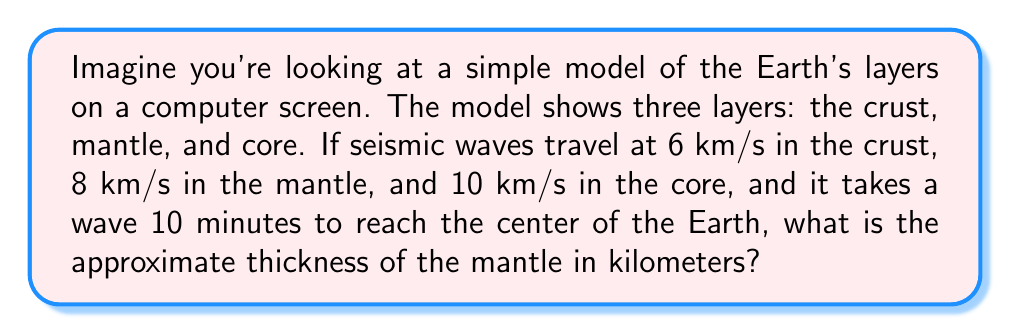Teach me how to tackle this problem. Let's break this down step-by-step:

1) First, we need to convert the time from minutes to seconds:
   10 minutes = 10 × 60 = 600 seconds

2) Now, we know that distance = speed × time. The total distance is the radius of the Earth, which we'll calculate.

3) We don't know the exact thickness of each layer, but we can make some assumptions based on general knowledge:
   - The crust is relatively thin, let's assume it's about 30 km thick
   - The core is about half the Earth's radius

4) Let's calculate the total distance the wave travels:
   $$ \text{Total distance} = 6 \frac{\text{km}}{\text{s}} \times 30\text{s} + 8 \frac{\text{km}}{\text{s}} \times t_1 + 10 \frac{\text{km}}{\text{s}} \times t_2 = 600\text{ km} $$
   Where $t_1$ is the time in the mantle and $t_2$ is the time in the core

5) We know that $t_1 + t_2 = 570\text{s}$ (600s - 30s in the crust)

6) If the core is half the radius, then $t_2 = \frac{570}{2} = 285\text{s}$

7) So, $t_1 = 570 - 285 = 285\text{s}$

8) Now we can calculate the distance traveled in the mantle:
   $$ \text{Mantle thickness} = 8 \frac{\text{km}}{\text{s}} \times 285\text{s} = 2280\text{ km} $$

Therefore, the approximate thickness of the mantle in this model is 2280 km.
Answer: 2280 km 